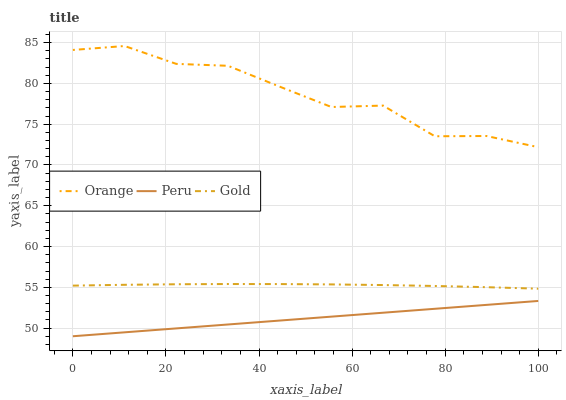Does Peru have the minimum area under the curve?
Answer yes or no. Yes. Does Orange have the maximum area under the curve?
Answer yes or no. Yes. Does Gold have the minimum area under the curve?
Answer yes or no. No. Does Gold have the maximum area under the curve?
Answer yes or no. No. Is Peru the smoothest?
Answer yes or no. Yes. Is Orange the roughest?
Answer yes or no. Yes. Is Gold the smoothest?
Answer yes or no. No. Is Gold the roughest?
Answer yes or no. No. Does Peru have the lowest value?
Answer yes or no. Yes. Does Gold have the lowest value?
Answer yes or no. No. Does Orange have the highest value?
Answer yes or no. Yes. Does Gold have the highest value?
Answer yes or no. No. Is Gold less than Orange?
Answer yes or no. Yes. Is Gold greater than Peru?
Answer yes or no. Yes. Does Gold intersect Orange?
Answer yes or no. No. 